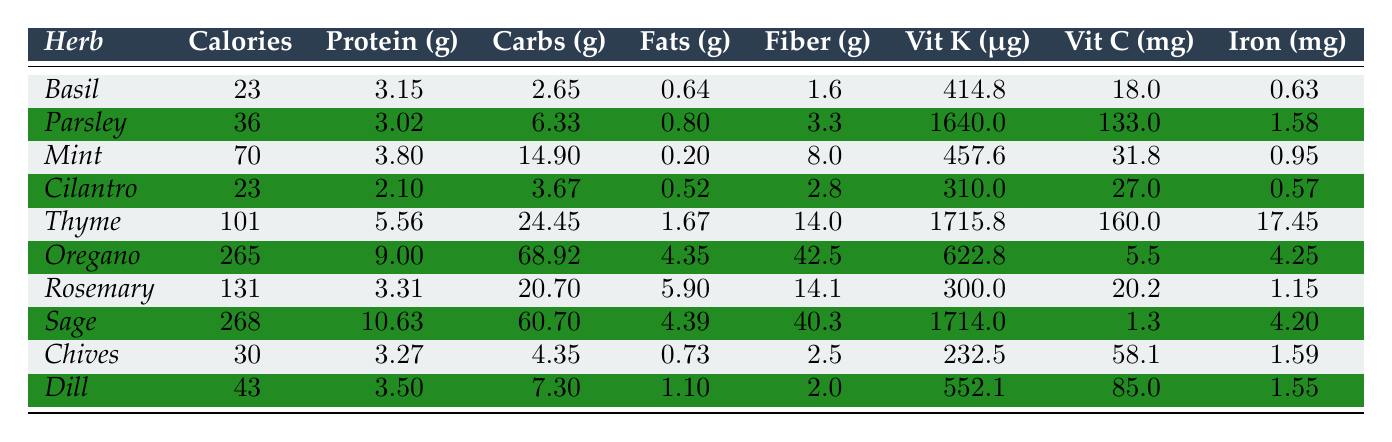What herb has the highest vitamin K content? The vitamin K content for each herb is listed in the table. By comparing the values, Sage has 1714 μg, which is greater than all other herbs listed.
Answer: Sage What is the total protein content in grams for Basil and Cilantro combined? The protein content for Basil is 3.15 g and for Cilantro is 2.1 g. Adding these gives 3.15 + 2.1 = 5.25 g.
Answer: 5.25 g Can you find an herb that has less than 30 calories per 100g? By examining the calories per 100g for each herb, Basil (23 calories) and Cilantro (23 calories) both have less than 30 calories.
Answer: Yes, Basil and Cilantro Which herb has the lowest fiber content? Looking at the fiber column, Basil has 1.6 g, which is the least compared to the others.
Answer: Basil Calculate the average vitamin C content for Mint, Dill, and Oregano. The vitamin C values are Mint (31.8 mg), Dill (85 mg), and Oregano (5.5 mg). Adding these gives 31.8 + 85 + 5.5 = 122.3 mg. Dividing by 3 gives 122.3 / 3 ≈ 40.77 mg.
Answer: 40.77 mg Is it true that Thyme has more carbohydrates than Mint? Thyme has 24.45 g of carbohydrates while Mint has 14.9 g. Since 24.45 > 14.9, this statement is true.
Answer: Yes What is the difference in iron content between Oregano and Rosemary? The iron content for Oregano is 4.25 mg, and for Rosemary, it is 1.15 mg. The difference is calculated as 4.25 - 1.15 = 3.1 mg.
Answer: 3.1 mg Which herb is the richest in protein per 100g? Checking the protein values, Sage has 10.63 g, which is higher than the protein content of the other herbs listed.
Answer: Sage What is the fiber content of Dill compared to Chives? Dill has 2.0 g of fiber while Chives has 2.5 g. Chives has more fiber than Dill (2.5 g > 2.0 g).
Answer: Chives has more fiber Find the herb with the highest calorie content. By examining the calories column, Sage has 268 calories, which is the highest compared to others.
Answer: Sage 